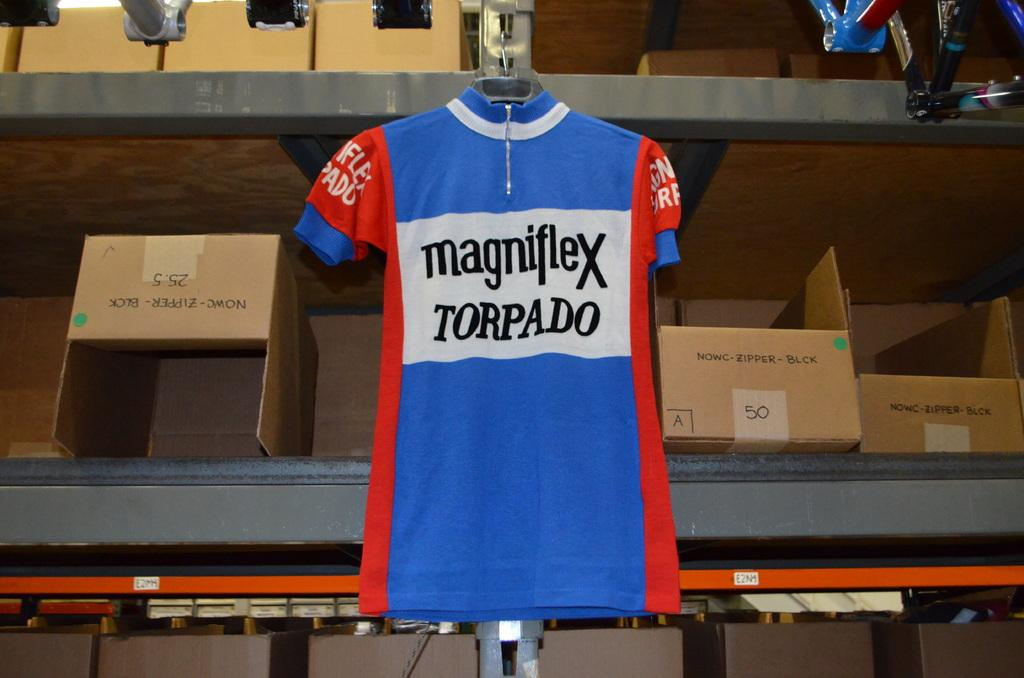Provide a one-sentence caption for the provided image. A blue and red jersey has "magniflex torpado" printed on it. 